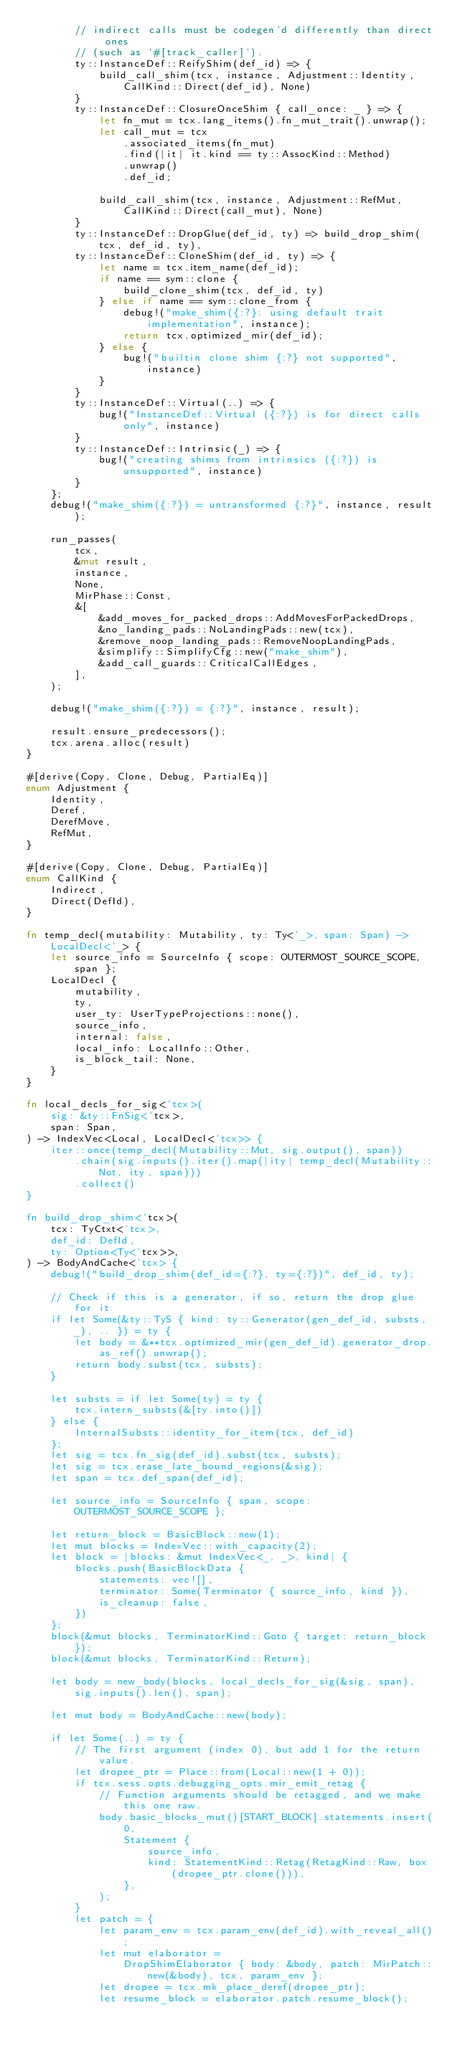<code> <loc_0><loc_0><loc_500><loc_500><_Rust_>        // indirect calls must be codegen'd differently than direct ones
        // (such as `#[track_caller]`).
        ty::InstanceDef::ReifyShim(def_id) => {
            build_call_shim(tcx, instance, Adjustment::Identity, CallKind::Direct(def_id), None)
        }
        ty::InstanceDef::ClosureOnceShim { call_once: _ } => {
            let fn_mut = tcx.lang_items().fn_mut_trait().unwrap();
            let call_mut = tcx
                .associated_items(fn_mut)
                .find(|it| it.kind == ty::AssocKind::Method)
                .unwrap()
                .def_id;

            build_call_shim(tcx, instance, Adjustment::RefMut, CallKind::Direct(call_mut), None)
        }
        ty::InstanceDef::DropGlue(def_id, ty) => build_drop_shim(tcx, def_id, ty),
        ty::InstanceDef::CloneShim(def_id, ty) => {
            let name = tcx.item_name(def_id);
            if name == sym::clone {
                build_clone_shim(tcx, def_id, ty)
            } else if name == sym::clone_from {
                debug!("make_shim({:?}: using default trait implementation", instance);
                return tcx.optimized_mir(def_id);
            } else {
                bug!("builtin clone shim {:?} not supported", instance)
            }
        }
        ty::InstanceDef::Virtual(..) => {
            bug!("InstanceDef::Virtual ({:?}) is for direct calls only", instance)
        }
        ty::InstanceDef::Intrinsic(_) => {
            bug!("creating shims from intrinsics ({:?}) is unsupported", instance)
        }
    };
    debug!("make_shim({:?}) = untransformed {:?}", instance, result);

    run_passes(
        tcx,
        &mut result,
        instance,
        None,
        MirPhase::Const,
        &[
            &add_moves_for_packed_drops::AddMovesForPackedDrops,
            &no_landing_pads::NoLandingPads::new(tcx),
            &remove_noop_landing_pads::RemoveNoopLandingPads,
            &simplify::SimplifyCfg::new("make_shim"),
            &add_call_guards::CriticalCallEdges,
        ],
    );

    debug!("make_shim({:?}) = {:?}", instance, result);

    result.ensure_predecessors();
    tcx.arena.alloc(result)
}

#[derive(Copy, Clone, Debug, PartialEq)]
enum Adjustment {
    Identity,
    Deref,
    DerefMove,
    RefMut,
}

#[derive(Copy, Clone, Debug, PartialEq)]
enum CallKind {
    Indirect,
    Direct(DefId),
}

fn temp_decl(mutability: Mutability, ty: Ty<'_>, span: Span) -> LocalDecl<'_> {
    let source_info = SourceInfo { scope: OUTERMOST_SOURCE_SCOPE, span };
    LocalDecl {
        mutability,
        ty,
        user_ty: UserTypeProjections::none(),
        source_info,
        internal: false,
        local_info: LocalInfo::Other,
        is_block_tail: None,
    }
}

fn local_decls_for_sig<'tcx>(
    sig: &ty::FnSig<'tcx>,
    span: Span,
) -> IndexVec<Local, LocalDecl<'tcx>> {
    iter::once(temp_decl(Mutability::Mut, sig.output(), span))
        .chain(sig.inputs().iter().map(|ity| temp_decl(Mutability::Not, ity, span)))
        .collect()
}

fn build_drop_shim<'tcx>(
    tcx: TyCtxt<'tcx>,
    def_id: DefId,
    ty: Option<Ty<'tcx>>,
) -> BodyAndCache<'tcx> {
    debug!("build_drop_shim(def_id={:?}, ty={:?})", def_id, ty);

    // Check if this is a generator, if so, return the drop glue for it
    if let Some(&ty::TyS { kind: ty::Generator(gen_def_id, substs, _), .. }) = ty {
        let body = &**tcx.optimized_mir(gen_def_id).generator_drop.as_ref().unwrap();
        return body.subst(tcx, substs);
    }

    let substs = if let Some(ty) = ty {
        tcx.intern_substs(&[ty.into()])
    } else {
        InternalSubsts::identity_for_item(tcx, def_id)
    };
    let sig = tcx.fn_sig(def_id).subst(tcx, substs);
    let sig = tcx.erase_late_bound_regions(&sig);
    let span = tcx.def_span(def_id);

    let source_info = SourceInfo { span, scope: OUTERMOST_SOURCE_SCOPE };

    let return_block = BasicBlock::new(1);
    let mut blocks = IndexVec::with_capacity(2);
    let block = |blocks: &mut IndexVec<_, _>, kind| {
        blocks.push(BasicBlockData {
            statements: vec![],
            terminator: Some(Terminator { source_info, kind }),
            is_cleanup: false,
        })
    };
    block(&mut blocks, TerminatorKind::Goto { target: return_block });
    block(&mut blocks, TerminatorKind::Return);

    let body = new_body(blocks, local_decls_for_sig(&sig, span), sig.inputs().len(), span);

    let mut body = BodyAndCache::new(body);

    if let Some(..) = ty {
        // The first argument (index 0), but add 1 for the return value.
        let dropee_ptr = Place::from(Local::new(1 + 0));
        if tcx.sess.opts.debugging_opts.mir_emit_retag {
            // Function arguments should be retagged, and we make this one raw.
            body.basic_blocks_mut()[START_BLOCK].statements.insert(
                0,
                Statement {
                    source_info,
                    kind: StatementKind::Retag(RetagKind::Raw, box (dropee_ptr.clone())),
                },
            );
        }
        let patch = {
            let param_env = tcx.param_env(def_id).with_reveal_all();
            let mut elaborator =
                DropShimElaborator { body: &body, patch: MirPatch::new(&body), tcx, param_env };
            let dropee = tcx.mk_place_deref(dropee_ptr);
            let resume_block = elaborator.patch.resume_block();</code> 